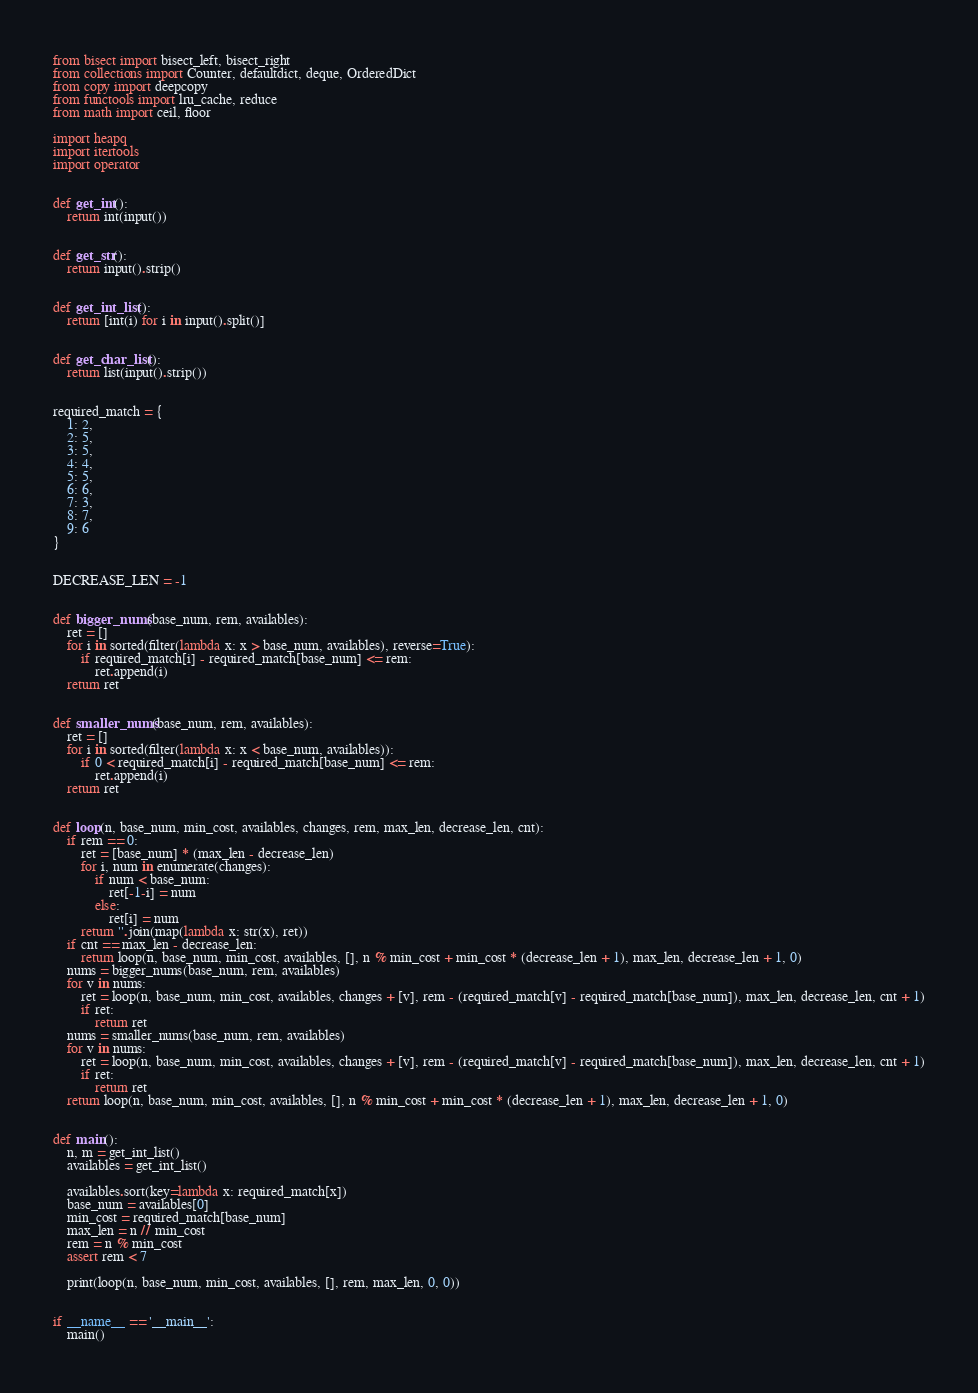Convert code to text. <code><loc_0><loc_0><loc_500><loc_500><_Python_>from bisect import bisect_left, bisect_right
from collections import Counter, defaultdict, deque, OrderedDict
from copy import deepcopy
from functools import lru_cache, reduce
from math import ceil, floor

import heapq
import itertools
import operator


def get_int():
    return int(input())


def get_str():
    return input().strip()


def get_int_list():
    return [int(i) for i in input().split()]


def get_char_list():
    return list(input().strip())


required_match = {
    1: 2,
    2: 5,
    3: 5,
    4: 4,
    5: 5,
    6: 6,
    7: 3,
    8: 7,
    9: 6
}


DECREASE_LEN = -1


def bigger_nums(base_num, rem, availables):
    ret = []
    for i in sorted(filter(lambda x: x > base_num, availables), reverse=True):
        if required_match[i] - required_match[base_num] <= rem:
            ret.append(i)
    return ret


def smaller_nums(base_num, rem, availables):
    ret = []
    for i in sorted(filter(lambda x: x < base_num, availables)):
        if 0 < required_match[i] - required_match[base_num] <= rem:
            ret.append(i)
    return ret


def loop(n, base_num, min_cost, availables, changes, rem, max_len, decrease_len, cnt):
    if rem == 0:
        ret = [base_num] * (max_len - decrease_len)
        for i, num in enumerate(changes):
            if num < base_num:
                ret[-1-i] = num
            else:
                ret[i] = num
        return ''.join(map(lambda x: str(x), ret))
    if cnt == max_len - decrease_len:
        return loop(n, base_num, min_cost, availables, [], n % min_cost + min_cost * (decrease_len + 1), max_len, decrease_len + 1, 0)
    nums = bigger_nums(base_num, rem, availables)
    for v in nums:
        ret = loop(n, base_num, min_cost, availables, changes + [v], rem - (required_match[v] - required_match[base_num]), max_len, decrease_len, cnt + 1)
        if ret:
            return ret
    nums = smaller_nums(base_num, rem, availables)
    for v in nums:
        ret = loop(n, base_num, min_cost, availables, changes + [v], rem - (required_match[v] - required_match[base_num]), max_len, decrease_len, cnt + 1)
        if ret:
            return ret
    return loop(n, base_num, min_cost, availables, [], n % min_cost + min_cost * (decrease_len + 1), max_len, decrease_len + 1, 0)


def main():
    n, m = get_int_list()
    availables = get_int_list()

    availables.sort(key=lambda x: required_match[x])
    base_num = availables[0]
    min_cost = required_match[base_num]
    max_len = n // min_cost
    rem = n % min_cost
    assert rem < 7

    print(loop(n, base_num, min_cost, availables, [], rem, max_len, 0, 0))


if __name__ == '__main__':
    main()
</code> 